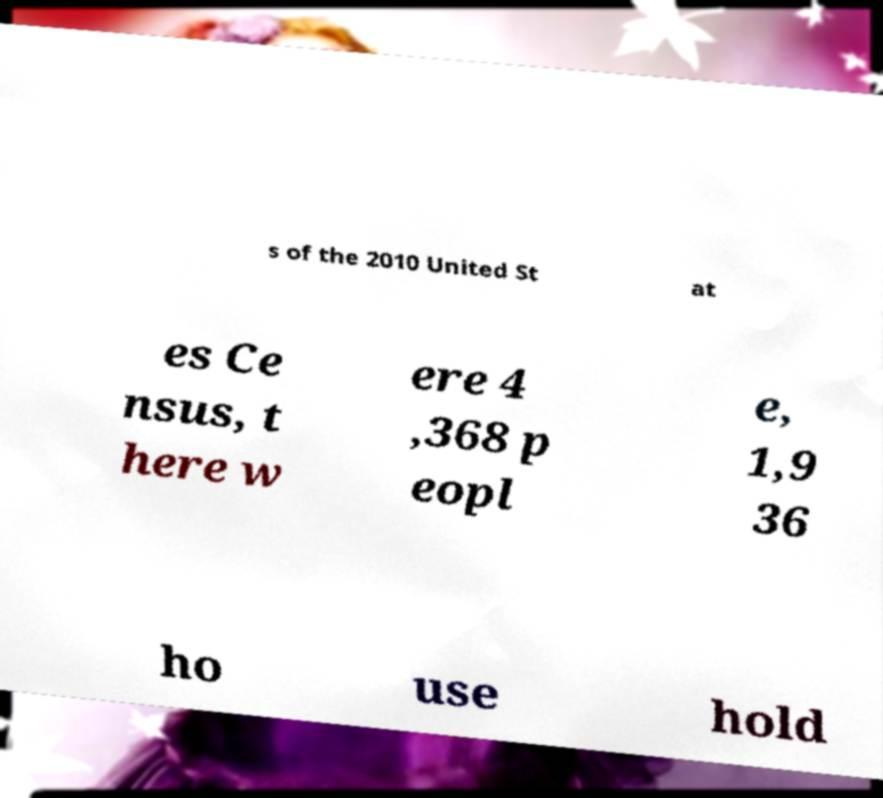Please identify and transcribe the text found in this image. s of the 2010 United St at es Ce nsus, t here w ere 4 ,368 p eopl e, 1,9 36 ho use hold 